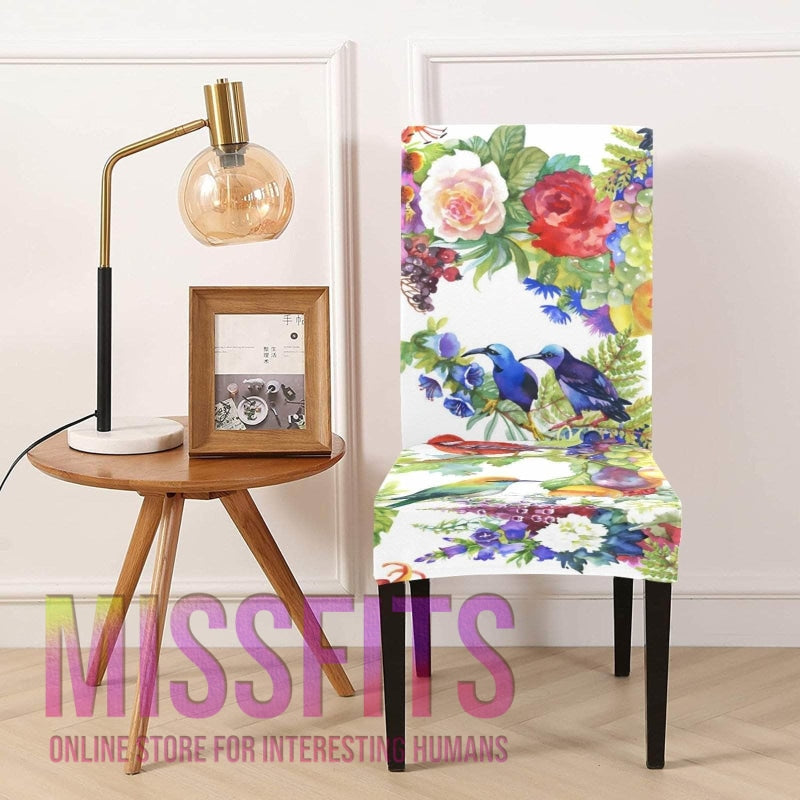Imagine this chair is part of a larger furniture collection, what items might you find in it? In a furniture collection that includes this chair, one might find similarly styled items such as a couch or settee adorned with complementing or matching floral patterns, vibrant throw pillows, an ottoman, and maybe a whimsical area rug, all creating a cohesive look. Accent pieces could include a variety of nature-themed decor such as botanical prints, decorative bird figures, or tropical-patterned curtains. 